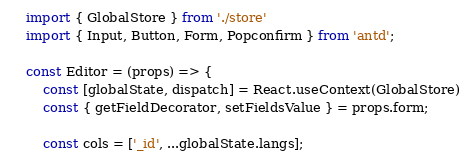Convert code to text. <code><loc_0><loc_0><loc_500><loc_500><_JavaScript_>import { GlobalStore } from './store'
import { Input, Button, Form, Popconfirm } from 'antd';

const Editor = (props) => {
    const [globalState, dispatch] = React.useContext(GlobalStore)
    const { getFieldDecorator, setFieldsValue } = props.form;

    const cols = ['_id', ...globalState.langs];
</code> 